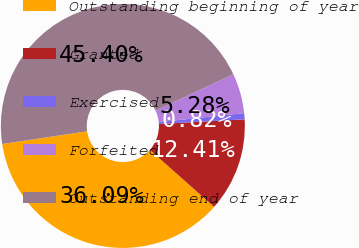<chart> <loc_0><loc_0><loc_500><loc_500><pie_chart><fcel>Outstanding beginning of year<fcel>Granted<fcel>Exercised<fcel>Forfeited<fcel>Outstanding end of year<nl><fcel>36.09%<fcel>12.41%<fcel>0.82%<fcel>5.28%<fcel>45.4%<nl></chart> 